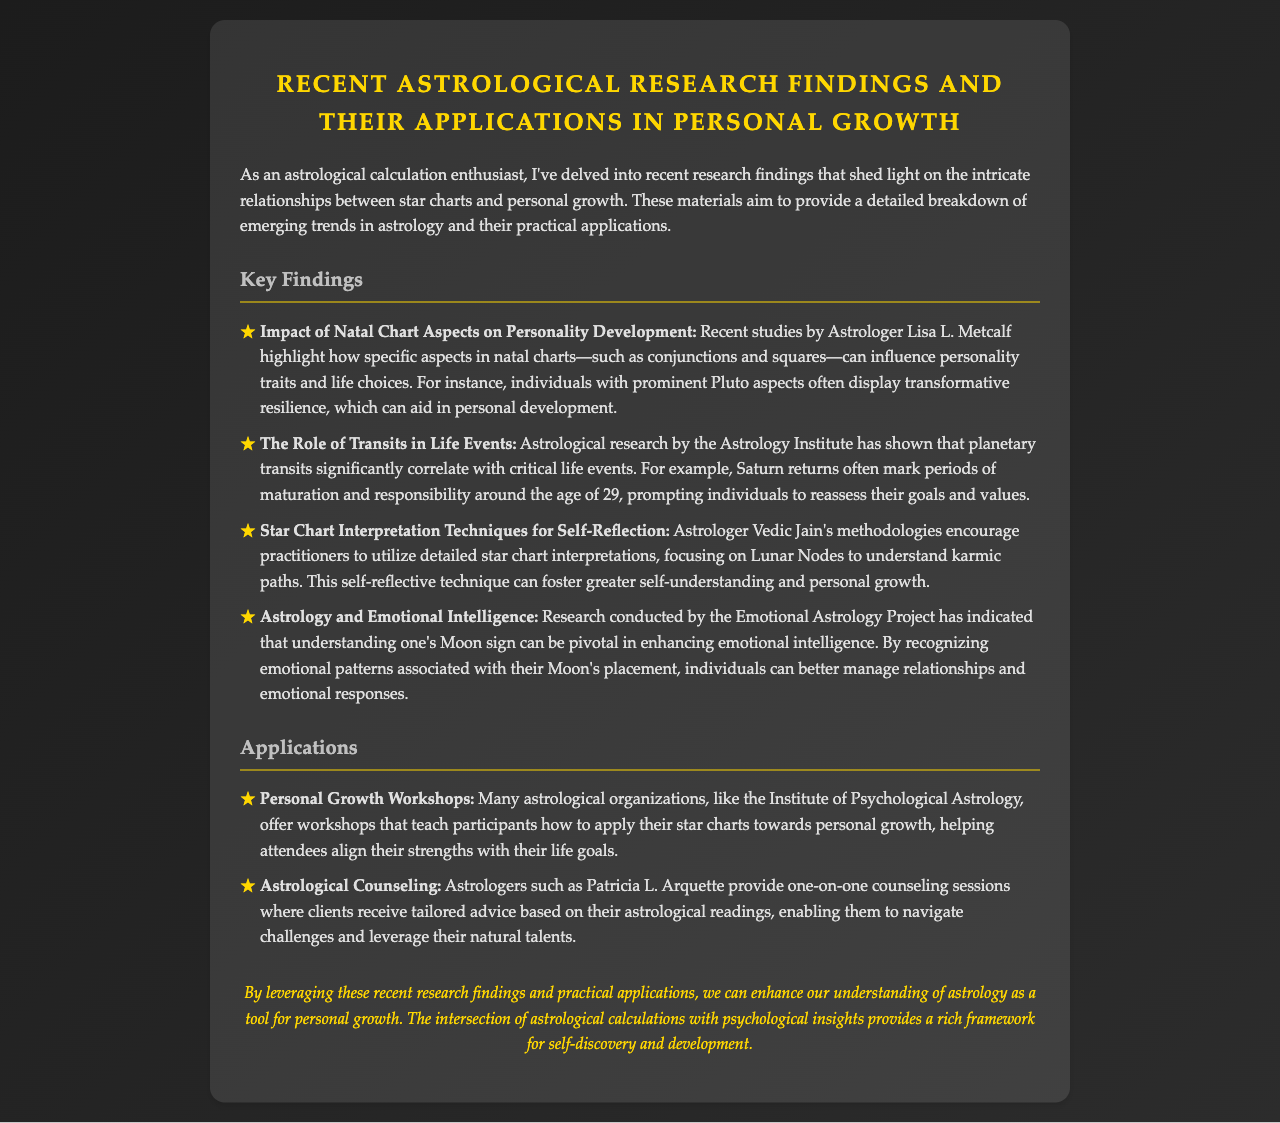What is the title of the document? The title of the document is found at the beginning, indicating the subject of the research findings and applications.
Answer: Recent Astrological Research Findings and Their Applications in Personal Growth Who conducted research on the impact of natal chart aspects? The document mentions a specific astrological researcher associated with the findings on natal chart aspects.
Answer: Lisa L. Metcalf What age is associated with Saturn returns? The document specifically states the age at which individuals typically experience Saturn returns and reassess their goals.
Answer: 29 Which astrological figure's methodologies focus on Lunar Nodes? The document identifies an astrologer who emphasizes Luna Nodes for understanding karmic paths.
Answer: Vedic Jain What type of workshops do the astrological organizations offer? The document discusses workshops aimed at applying star charts for a certain purpose.
Answer: Personal Growth Workshops How does understanding one's Moon sign enhance emotional intelligence? The document notes that recognizing certain aspects can lead to better management in which area?
Answer: Relationships and emotional responses What is one of the practical applications mentioned in the document? The document includes examples of how astrology is used practically in certain situations.
Answer: Astrological Counseling What is the conclusion about recent research findings in astrology? The document summarizes the significance of the findings and their impact on personal development.
Answer: Enhance our understanding of astrology as a tool for personal growth 